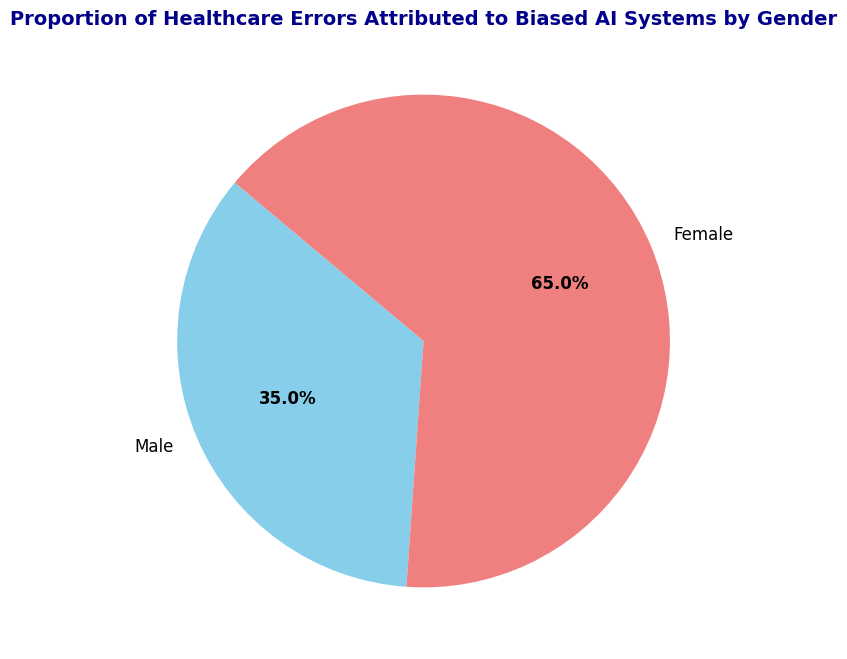Is the proportion of healthcare errors attributed to biased AI systems higher for males or females? The figure shows that the proportion for males is 35%, while for females it is 65%. Thus, the proportion is higher for females.
Answer: Females What is the percentage of healthcare errors attributed to biased AI systems for males? By referring to the pie chart, we can see the percentage labeled for males, which is 35%.
Answer: 35% What is the difference in the proportion of healthcare errors between males and females? The proportion for males is 35% and for females is 65%. Therefore, the difference is 65% - 35%.
Answer: 30% How much more likely are healthcare errors attributed to biased AI for females compared to males? The proportion for females is 65% and for males is 35%. To find how much more likely, we calculate (65% / 35%).
Answer: Approximately 1.86 times What is the combined proportion of healthcare errors attributed to biased AI systems for both genders? Since the pie chart represents the whole as 100%, the combined proportion for both males and females is 100%.
Answer: 100% Which gender has a pie segment with a light coral color? Looking at the figure, the segment with the light coral color corresponds to females.
Answer: Females What is the visual representation style of the largest segment in the pie chart? The largest segment is for females, which is represented in light coral color and takes up more than half of the pie chart.
Answer: Light coral, more than half If you combine 10 cases of healthcare errors attributed to biased AI, how many of those would be for females? If 65% of errors are attributed to females, then out of 10 cases, 65% of 10 is 6.5 cases.
Answer: 6.5 How many times greater is the proportion of healthcare errors attributed to biased AI for females compared to that for males? The proportion for females is 65% and for males is 35%. To find how many times greater, we calculate (65 / 35).
Answer: Approximately 1.86 What visual attribute differentiates the error proportions for males and females in the pie chart? The error proportions for males and females are differentiated by different colors: skyblue for males and light coral for females.
Answer: Colors 